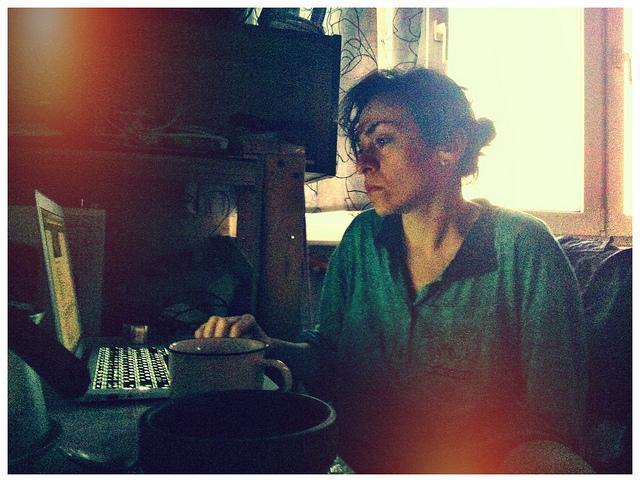How many computers are present?
Give a very brief answer. 1. 